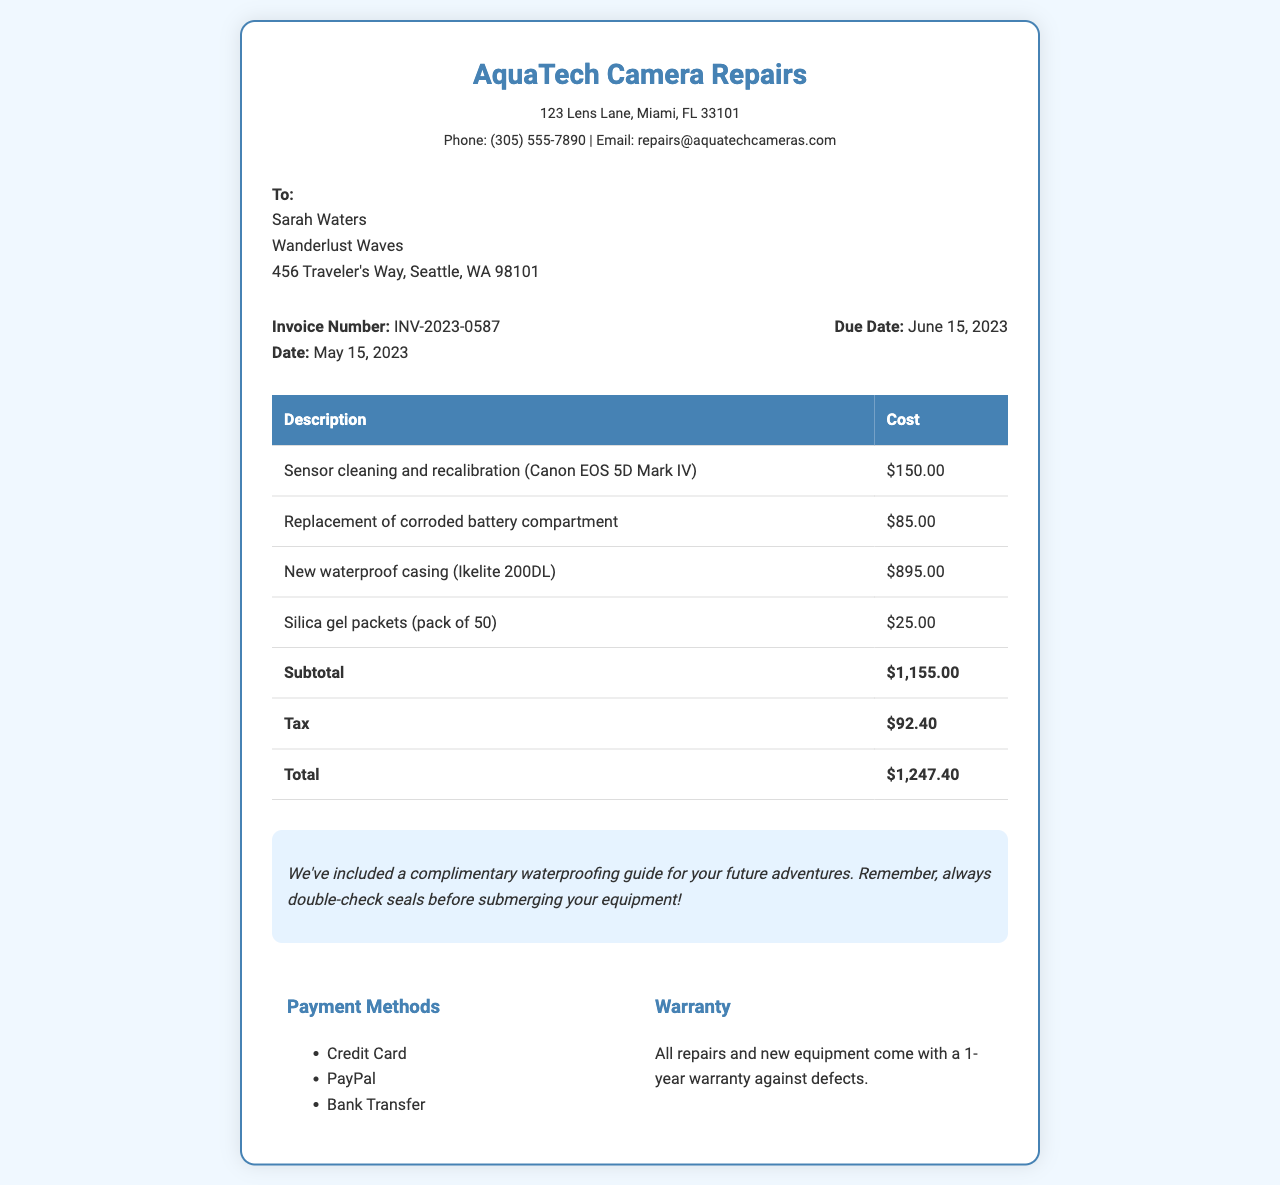What is the invoice number? The invoice number is designated for tracking and is found in the invoice details section.
Answer: INV-2023-0587 What is the date of the invoice? The date of the invoice can be found under the invoice details section.
Answer: May 15, 2023 What is the cost of the new waterproof casing? The cost of the waterproof casing is listed in the table of itemized costs.
Answer: $895.00 What is the total amount due? The total amount due is found at the bottom of the itemized cost table.
Answer: $1,247.40 What is included with the invoice as a note? The note section provides additional information related to the service or products.
Answer: A complimentary waterproofing guide for your future adventures What payment methods are available? The payment methods can be found in the payment methods section of the document.
Answer: Credit Card, PayPal, Bank Transfer What warranty is provided with repairs and new equipment? The warranty details are typically noted towards the end of the document.
Answer: 1-year warranty against defects What address is listed for AquaTech Camera Repairs? The address is located in the header section of the document.
Answer: 123 Lens Lane, Miami, FL 33101 What is the due date for the invoice? The due date can be found next to the invoice date in the invoice details section.
Answer: June 15, 2023 